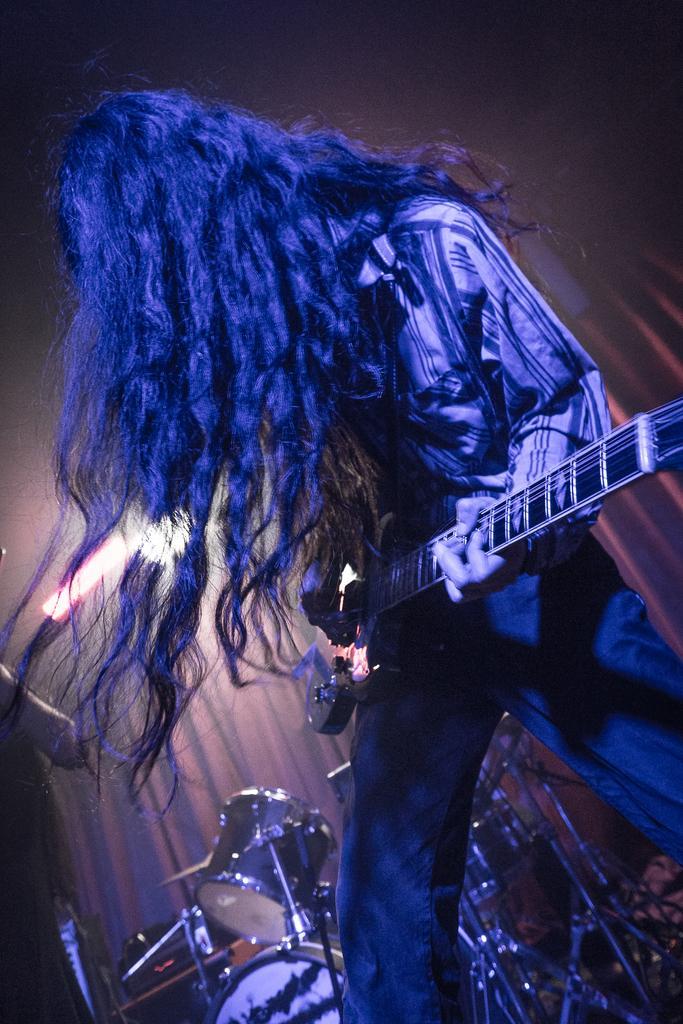Describe this image in one or two sentences. There is a person in a shirt, standing, holding and playing a guitar, near another person who is standing on the stage. In the background, there are drums, there is a light near a curtain and there is a roof. 